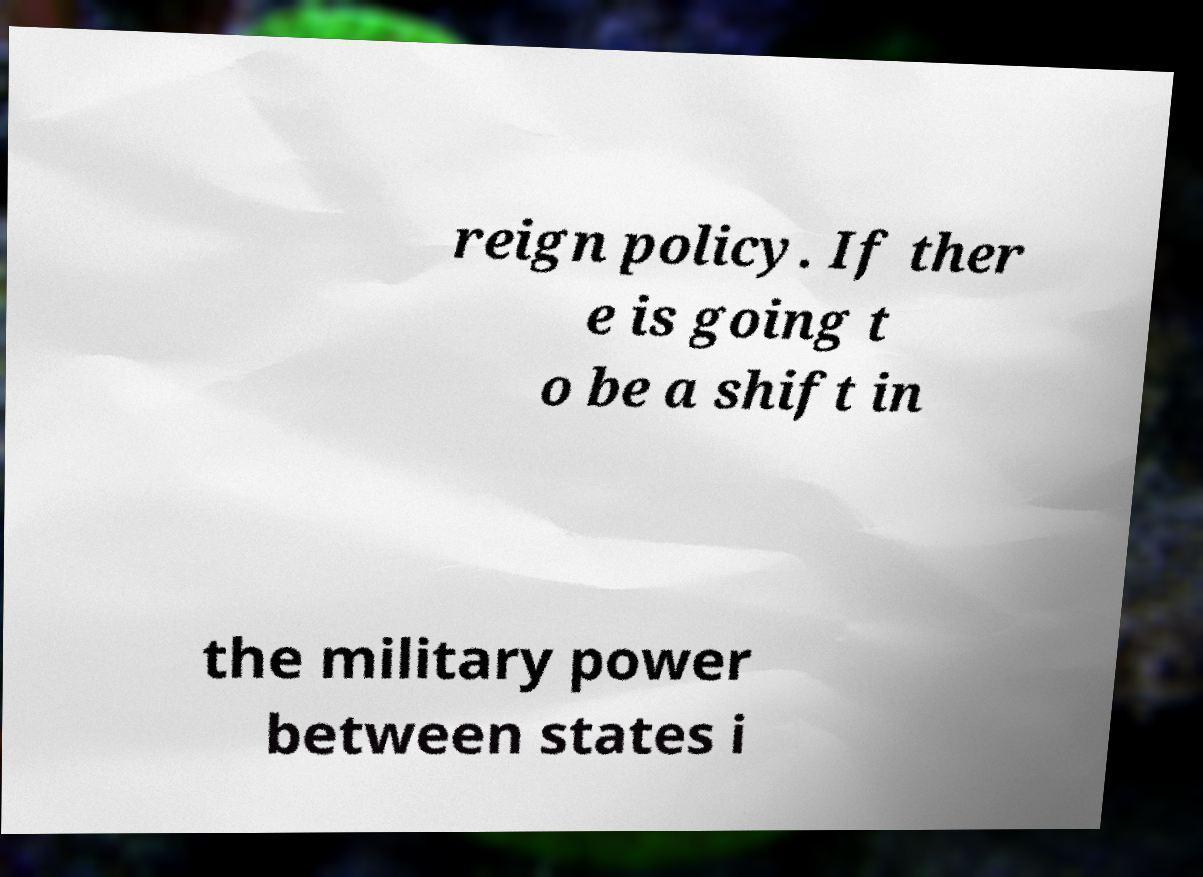Can you accurately transcribe the text from the provided image for me? reign policy. If ther e is going t o be a shift in the military power between states i 